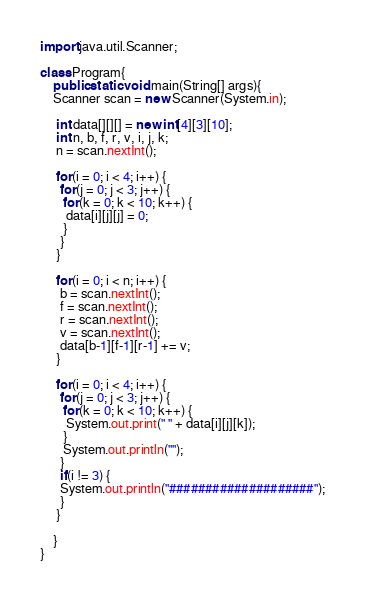Convert code to text. <code><loc_0><loc_0><loc_500><loc_500><_Java_>import java.util.Scanner;

class Program{
	public static void main(String[] args){
	Scanner scan = new Scanner(System.in);

	 int data[][][] = new int[4][3][10];
	 int n, b, f, r, v, i, j, k;
	 n = scan.nextInt();
	   
	 for(i = 0; i < 4; i++) {
	  for(j = 0; j < 3; j++) {
	   for(k = 0; k < 10; k++) {
	    data[i][j][j] = 0;
	   }
	  }
	 }
	   
	 for(i = 0; i < n; i++) {
	  b = scan.nextInt();
	  f = scan.nextInt();
	  r = scan.nextInt();
	  v = scan.nextInt();
	  data[b-1][f-1][r-1] += v;
	 }
	   
	 for(i = 0; i < 4; i++) {
	  for(j = 0; j < 3; j++) {
	   for(k = 0; k < 10; k++) {
		System.out.print(" " + data[i][j][k]);
	   }
	   System.out.println("");
	  }
	  if(i != 3) {
	  System.out.println("####################");
	  }
	 }

	}
}</code> 